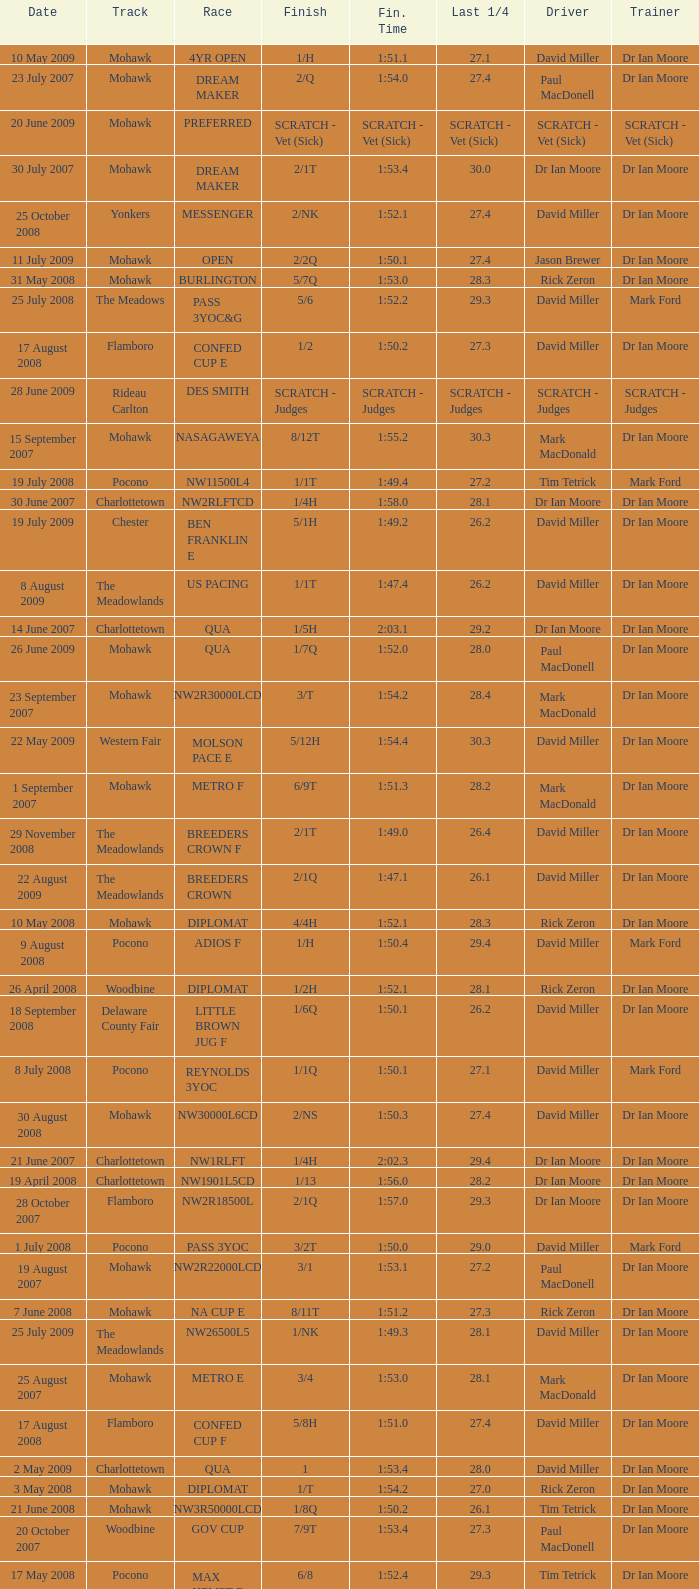What is the finishing time with a 2/1q finish on the Meadowlands track? 1:47.1. 